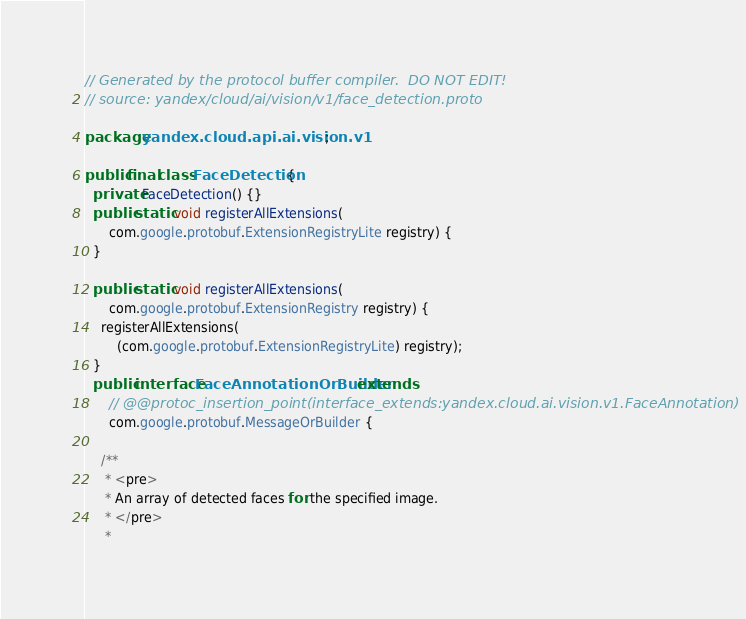<code> <loc_0><loc_0><loc_500><loc_500><_Java_>// Generated by the protocol buffer compiler.  DO NOT EDIT!
// source: yandex/cloud/ai/vision/v1/face_detection.proto

package yandex.cloud.api.ai.vision.v1;

public final class FaceDetection {
  private FaceDetection() {}
  public static void registerAllExtensions(
      com.google.protobuf.ExtensionRegistryLite registry) {
  }

  public static void registerAllExtensions(
      com.google.protobuf.ExtensionRegistry registry) {
    registerAllExtensions(
        (com.google.protobuf.ExtensionRegistryLite) registry);
  }
  public interface FaceAnnotationOrBuilder extends
      // @@protoc_insertion_point(interface_extends:yandex.cloud.ai.vision.v1.FaceAnnotation)
      com.google.protobuf.MessageOrBuilder {

    /**
     * <pre>
     * An array of detected faces for the specified image.
     * </pre>
     *</code> 